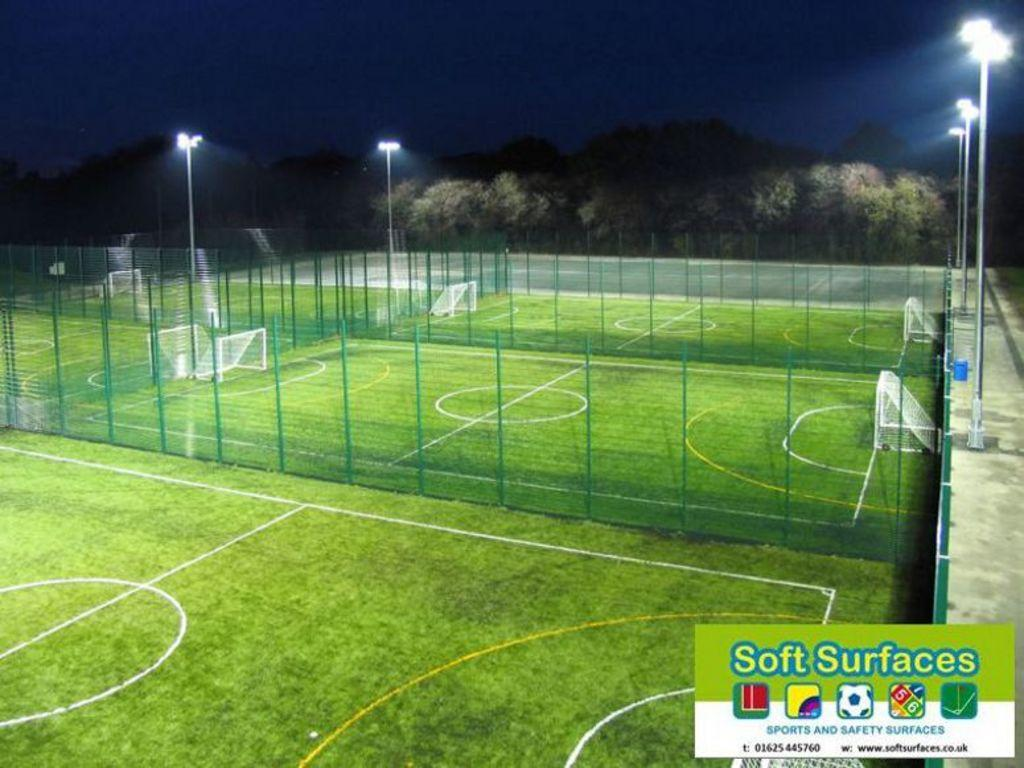<image>
Create a compact narrative representing the image presented. a sports arena with Soft Surfaces written in the bottom corner 